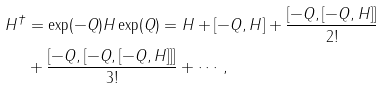<formula> <loc_0><loc_0><loc_500><loc_500>H ^ { \dagger } & = \exp ( - Q ) H \exp ( Q ) = H + [ - Q , H ] + \frac { [ - Q , [ - Q , H ] ] } { 2 ! } \\ & + \frac { [ - Q , [ - Q , [ - Q , H ] ] ] } { 3 ! } + \cdots ,</formula> 